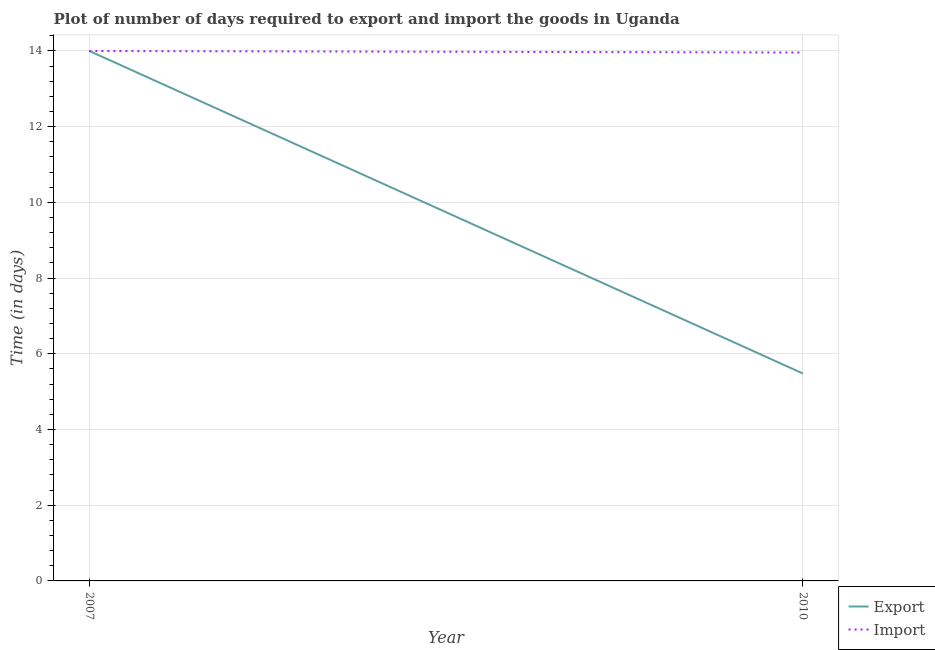Is the number of lines equal to the number of legend labels?
Provide a succinct answer. Yes. What is the time required to import in 2007?
Your answer should be compact. 14. Across all years, what is the minimum time required to import?
Your answer should be compact. 13.96. In which year was the time required to import minimum?
Offer a very short reply. 2010. What is the total time required to import in the graph?
Provide a short and direct response. 27.96. What is the difference between the time required to import in 2007 and that in 2010?
Give a very brief answer. 0.04. What is the difference between the time required to import in 2007 and the time required to export in 2010?
Ensure brevity in your answer.  8.52. What is the average time required to import per year?
Keep it short and to the point. 13.98. In the year 2007, what is the difference between the time required to export and time required to import?
Provide a succinct answer. 0. What is the ratio of the time required to import in 2007 to that in 2010?
Your answer should be very brief. 1. Does the time required to export monotonically increase over the years?
Your answer should be compact. No. Is the time required to import strictly less than the time required to export over the years?
Your answer should be very brief. No. How many lines are there?
Give a very brief answer. 2. How many legend labels are there?
Make the answer very short. 2. How are the legend labels stacked?
Give a very brief answer. Vertical. What is the title of the graph?
Give a very brief answer. Plot of number of days required to export and import the goods in Uganda. What is the label or title of the Y-axis?
Offer a terse response. Time (in days). What is the Time (in days) in Export in 2007?
Your response must be concise. 14. What is the Time (in days) in Import in 2007?
Offer a terse response. 14. What is the Time (in days) of Export in 2010?
Your response must be concise. 5.48. What is the Time (in days) in Import in 2010?
Ensure brevity in your answer.  13.96. Across all years, what is the minimum Time (in days) in Export?
Offer a terse response. 5.48. Across all years, what is the minimum Time (in days) of Import?
Give a very brief answer. 13.96. What is the total Time (in days) of Export in the graph?
Your answer should be compact. 19.48. What is the total Time (in days) of Import in the graph?
Your response must be concise. 27.96. What is the difference between the Time (in days) in Export in 2007 and that in 2010?
Give a very brief answer. 8.52. What is the average Time (in days) in Export per year?
Give a very brief answer. 9.74. What is the average Time (in days) of Import per year?
Make the answer very short. 13.98. In the year 2010, what is the difference between the Time (in days) in Export and Time (in days) in Import?
Make the answer very short. -8.48. What is the ratio of the Time (in days) of Export in 2007 to that in 2010?
Your answer should be very brief. 2.55. What is the ratio of the Time (in days) in Import in 2007 to that in 2010?
Your answer should be compact. 1. What is the difference between the highest and the second highest Time (in days) of Export?
Your response must be concise. 8.52. What is the difference between the highest and the second highest Time (in days) in Import?
Keep it short and to the point. 0.04. What is the difference between the highest and the lowest Time (in days) of Export?
Provide a short and direct response. 8.52. What is the difference between the highest and the lowest Time (in days) of Import?
Ensure brevity in your answer.  0.04. 